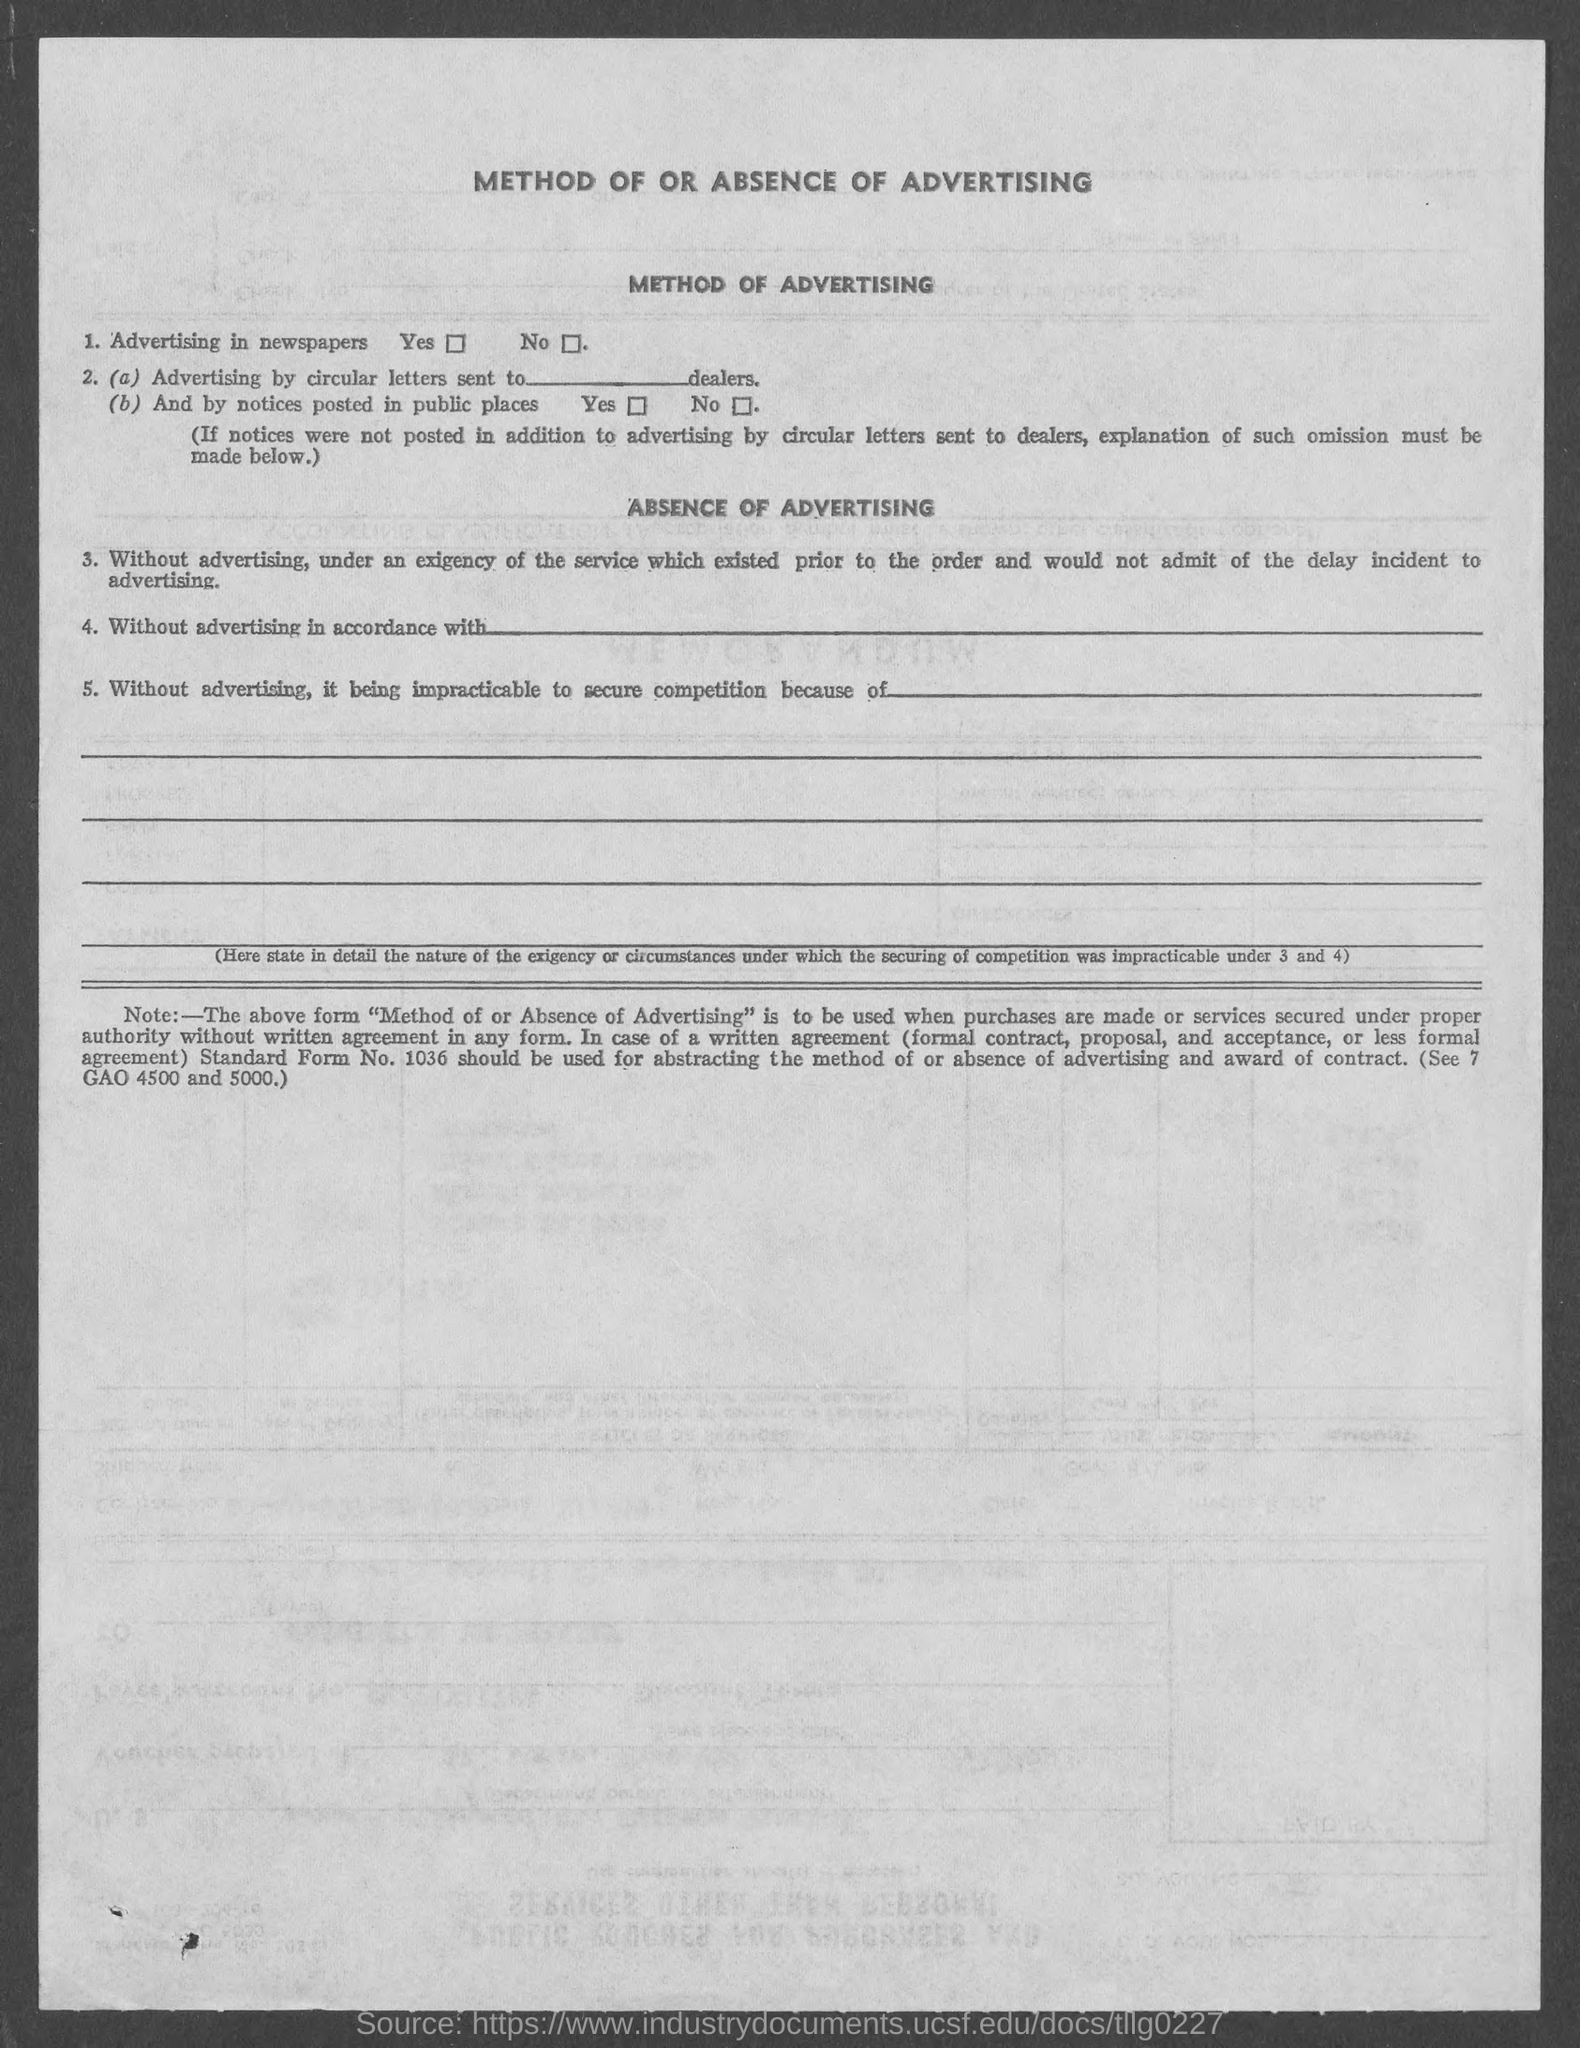What is the heading at top of the page ?
Offer a very short reply. Method of or absence of advertising. 